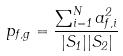<formula> <loc_0><loc_0><loc_500><loc_500>p _ { f , g } = \frac { \sum _ { i = 1 } ^ { N } a _ { f , i } ^ { 2 } } { | S _ { 1 } | | S _ { 2 } | }</formula> 